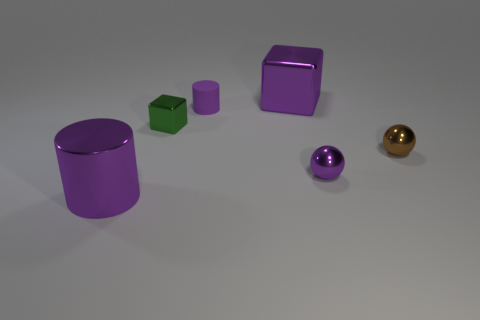Do any of the objects have the same shape but different sizes? Yes, there are two purple cylinders of different sizes visible in the image.  What can you tell me about the lighting in the scene? The lighting in the scene is diffuse with soft shadows, indicating that the light source is not extremely harsh or direct. 